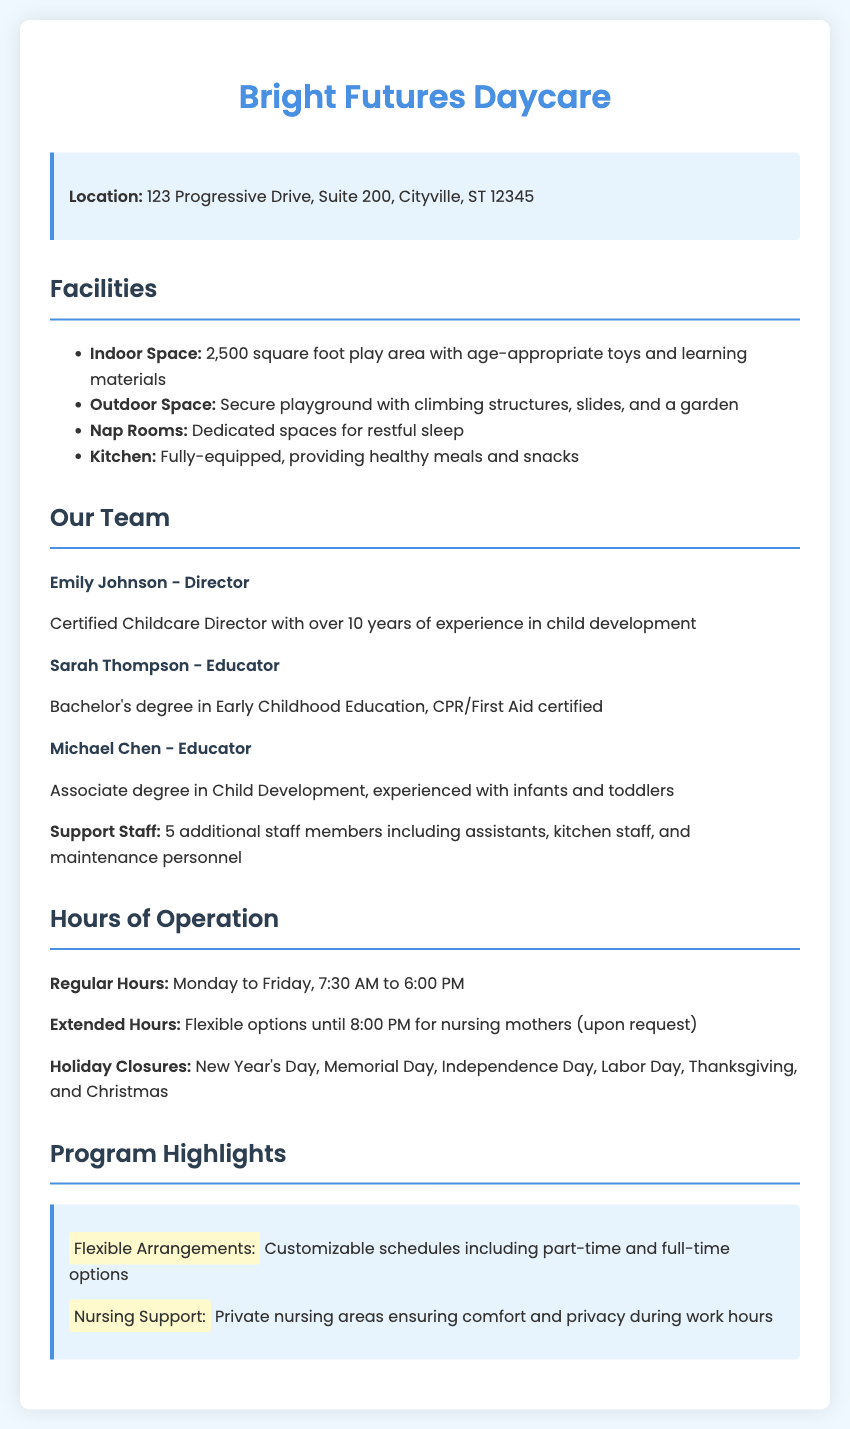what is the location of the daycare? The location of the daycare is explicitly stated in the document.
Answer: 123 Progressive Drive, Suite 200, Cityville, ST 12345 how many square feet is the indoor play area? The document provides the size of the indoor play area as part of the facilities information.
Answer: 2,500 square foot who is the director of the daycare? The document lists the staff members, including their roles and qualifications, providing the name of the director.
Answer: Emily Johnson what are the regular hours of operation? The regular operating hours are outlined in the hours of operation section of the document.
Answer: Monday to Friday, 7:30 AM to 6:00 PM how many additional staff members are there? The document specifies the support staff count in the description of the team.
Answer: 5 what flexibility options are available for nursing mothers? The document highlights customizable schedules and nursing support in the program highlights section.
Answer: Flexible options until 8:00 PM what is the outdoor space feature mentioned? The document mentions specific features of the outdoor space in the facilities section.
Answer: Secure playground with climbing structures, slides, and a garden what educational qualification does Sarah Thompson have? The document describes each educator's qualifications, highlighting Sarah Thompson's credentials.
Answer: Bachelor's degree in Early Childhood Education which holidays is the daycare closed? The document lists specific holidays when the daycare is not operational.
Answer: New Year's Day, Memorial Day, Independence Day, Labor Day, Thanksgiving, and Christmas 